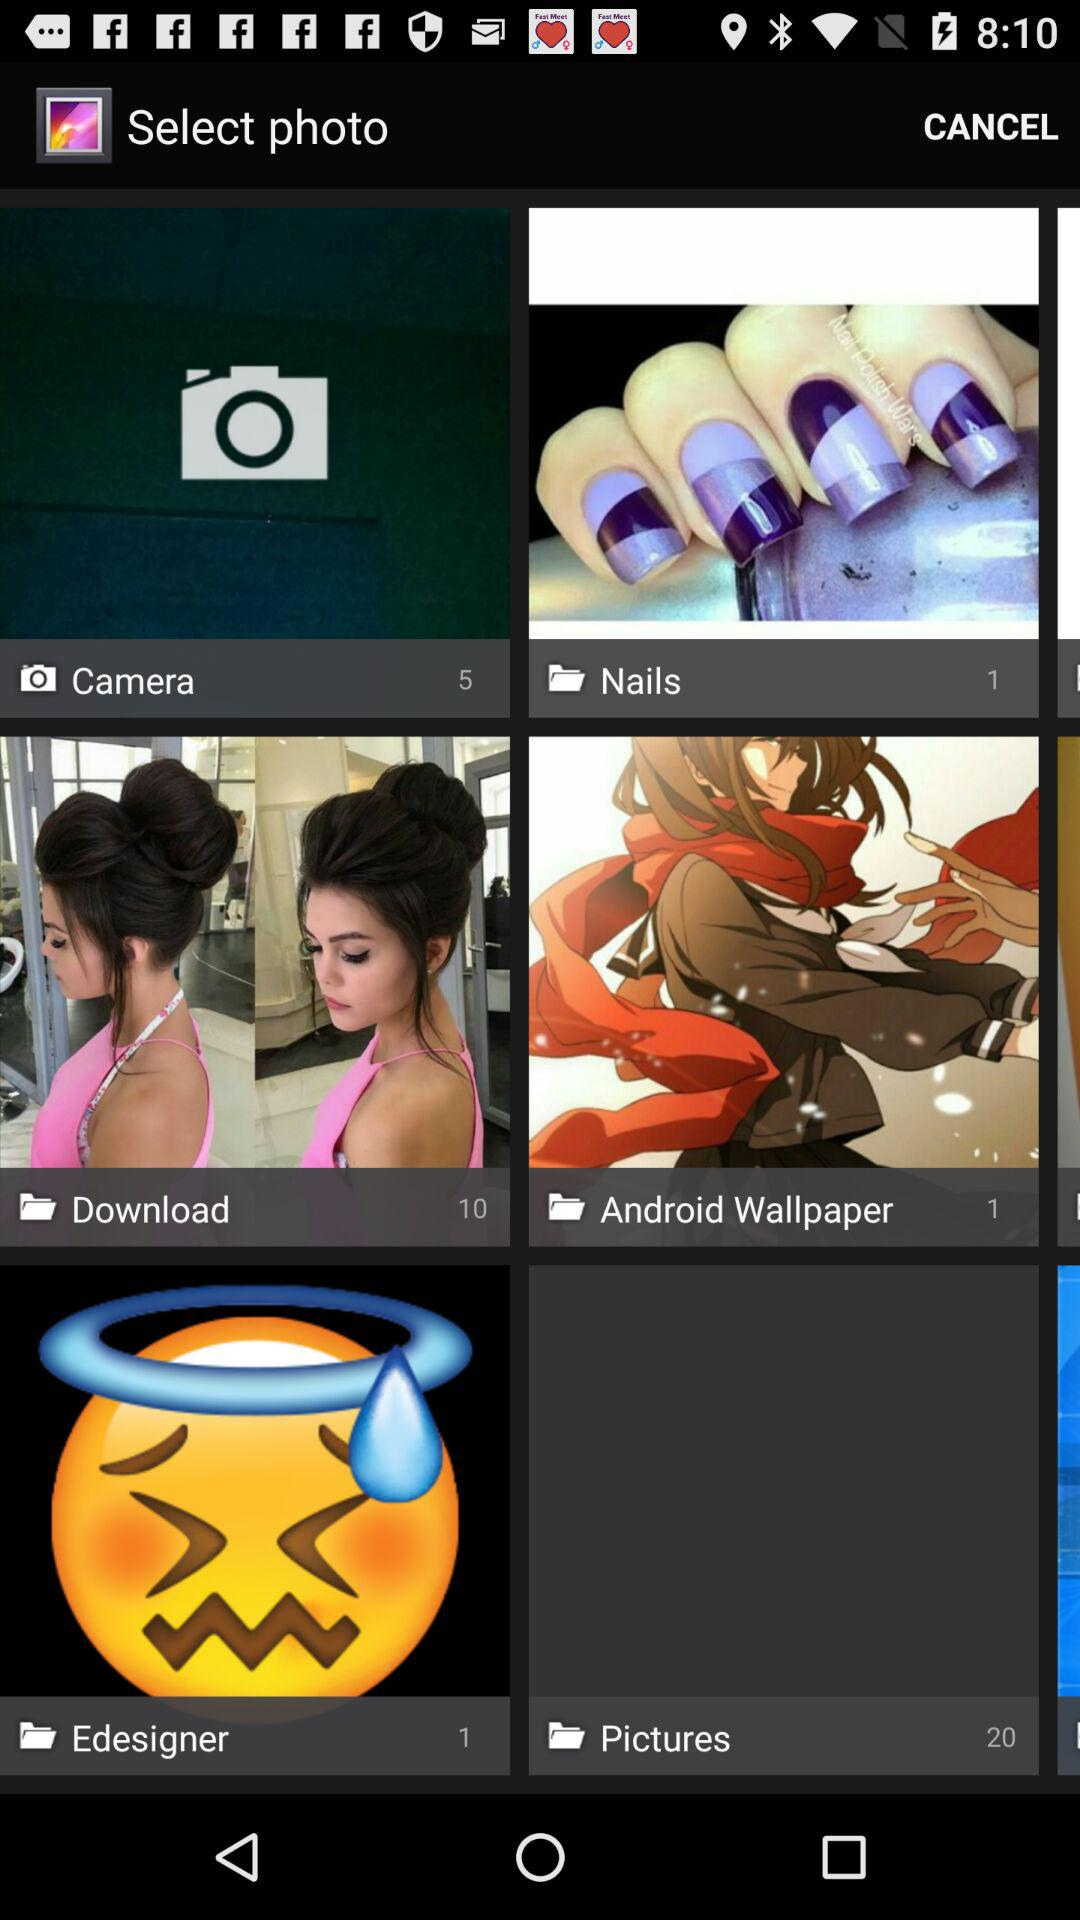Who posted these images?
When the provided information is insufficient, respond with <no answer>. <no answer> 